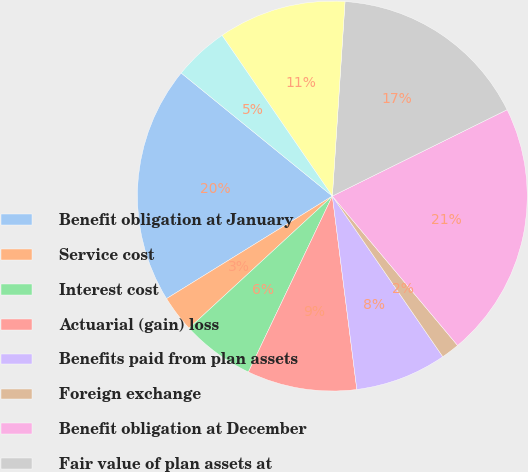Convert chart to OTSL. <chart><loc_0><loc_0><loc_500><loc_500><pie_chart><fcel>Benefit obligation at January<fcel>Service cost<fcel>Interest cost<fcel>Actuarial (gain) loss<fcel>Benefits paid from plan assets<fcel>Foreign exchange<fcel>Benefit obligation at December<fcel>Fair value of plan assets at<fcel>Actual return on plan assets<fcel>Company contributions<nl><fcel>19.69%<fcel>3.04%<fcel>6.06%<fcel>9.09%<fcel>7.58%<fcel>1.52%<fcel>21.2%<fcel>16.66%<fcel>10.61%<fcel>4.55%<nl></chart> 